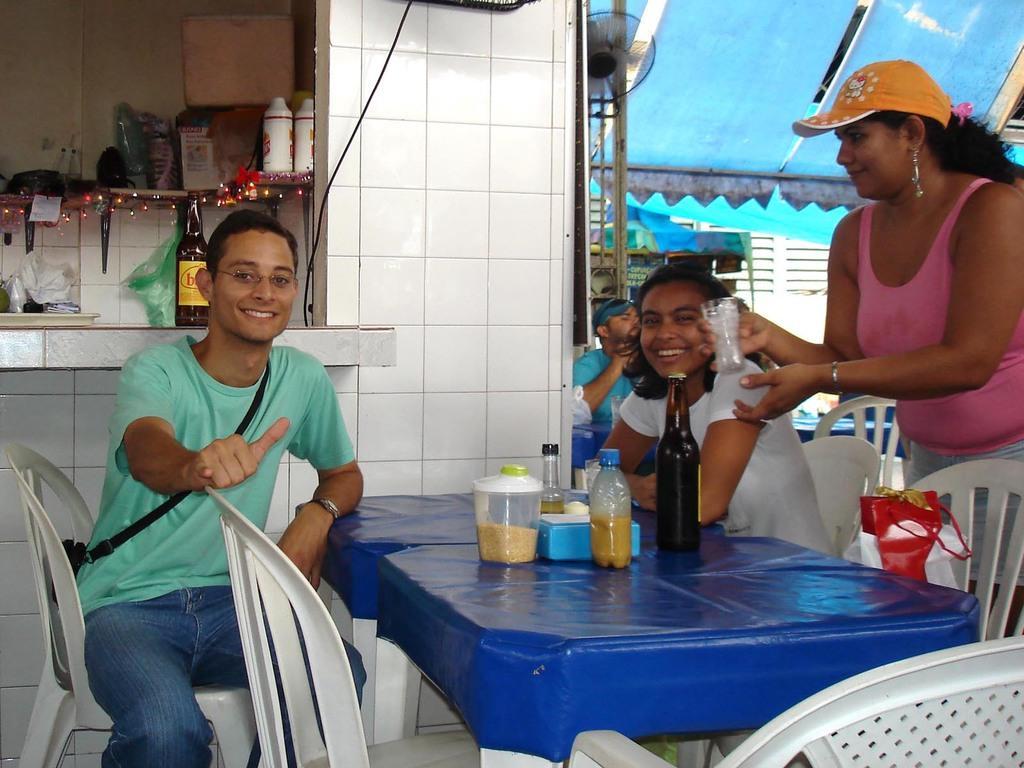Please provide a concise description of this image. This man and this women are sitting on a chairs and smiling. On this table there are bottles, box and jar. On this chair there is a bag. This woman is standing, smiling, wore cap and holding a glass. On this table there are bottles, box and things. This is tent in blue color. Far a person is siting on a chair. 